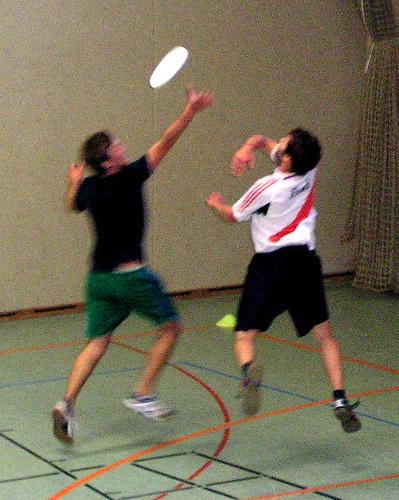Is the man in the black shirt going up or down?
Quick response, please. Up. Are they playing outside?
Give a very brief answer. No. What are the men reaching for?
Short answer required. Frisbee. 